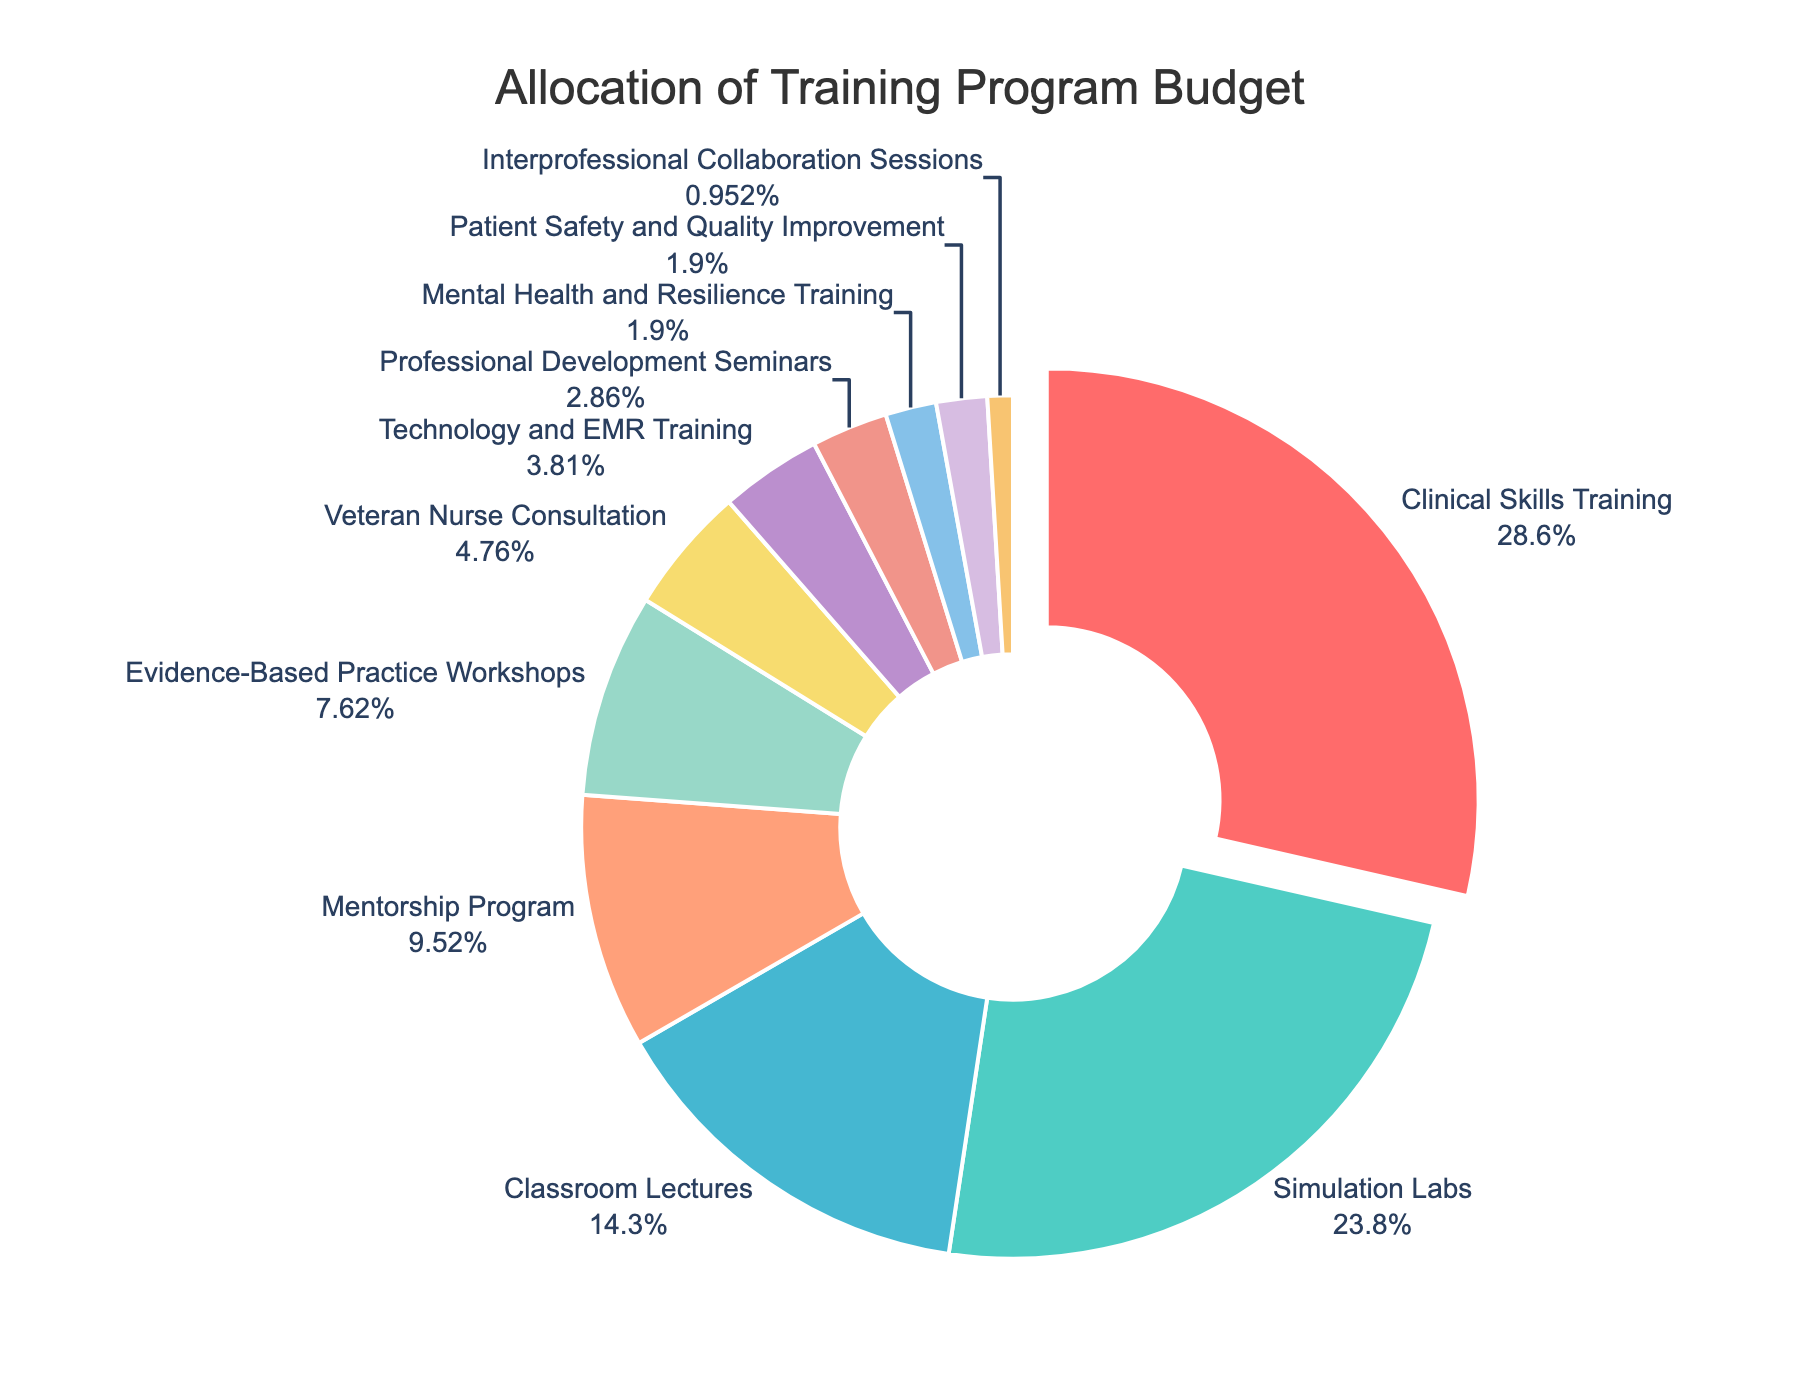What percentage of the budget is allocated to Clinical Skills Training and Simulation Labs combined? The percentage for Clinical Skills Training is 30% and for Simulation Labs is 25%. Adding them together, we get 30% + 25% = 55%.
Answer: 55% Which component has the smallest budget allocation? By inspecting the chart, the component with the smallest slice is Interprofessional Collaboration Sessions, which is given 1% of the total budget.
Answer: Interprofessional Collaboration Sessions How much more is allocated to Classroom Lectures than Mentorship Program? Classroom Lectures are allocated 15% and Mentorship Program is allocated 10%. The difference between them is 15% - 10% = 5%.
Answer: 5% Are Evidence-Based Practice Workshops allocated more or less budget than Veteran Nurse Consultation and Mental Health and Resilience Training combined? Evidence-Based Practice Workshops have 8%, while Veteran Nurse Consultation and Mental Health and Resilience Training combined have 5% + 2% = 7%. Therefore, Evidence-Based Practice Workshops have a higher allocation.
Answer: More Which section of the pie chart is pulled out from the center? Observing the chart, the section for Clinical Skills Training is pulled slightly out from the center.
Answer: Clinical Skills Training What is the combined percentage allocation for Technology and EMR Training and Professional Development Seminars? Technology and EMR Training accounts for 4% and Professional Development Seminars for 3%. Together, their allocation is 4% + 3% = 7%.
Answer: 7% Is the allocation for Simulation Labs more than double the allocation for Classroom Lectures? Simulation Labs have an allocation of 25%, while Classroom Lectures have 15%. Doubling Classroom Lectures gives 15% × 2 = 30%, which is more than Simulation Labs' 25%.
Answer: No Which component has a higher budget allocation: Mental Health and Resilience Training or Patient Safety and Quality Improvement? Observing the chart, both Mental Health and Resilience Training and Patient Safety and Quality Improvement are each allocated 2%.
Answer: Equal What is the total percentage allocation for the three largest components? The three largest components are Clinical Skills Training (30%), Simulation Labs (25%), and Classroom Lectures (15%). Adding them together: 30% + 25% + 15% = 70%.
Answer: 70% By how much does the allocation for Evidence-Based Practice Workshops exceed the allocation for Interprofessional Collaboration Sessions? Evidence-Based Practice Workshops have an 8% allocation while Interprofessional Collaboration Sessions have 1%. The difference is 8% - 1% = 7%.
Answer: 7% 